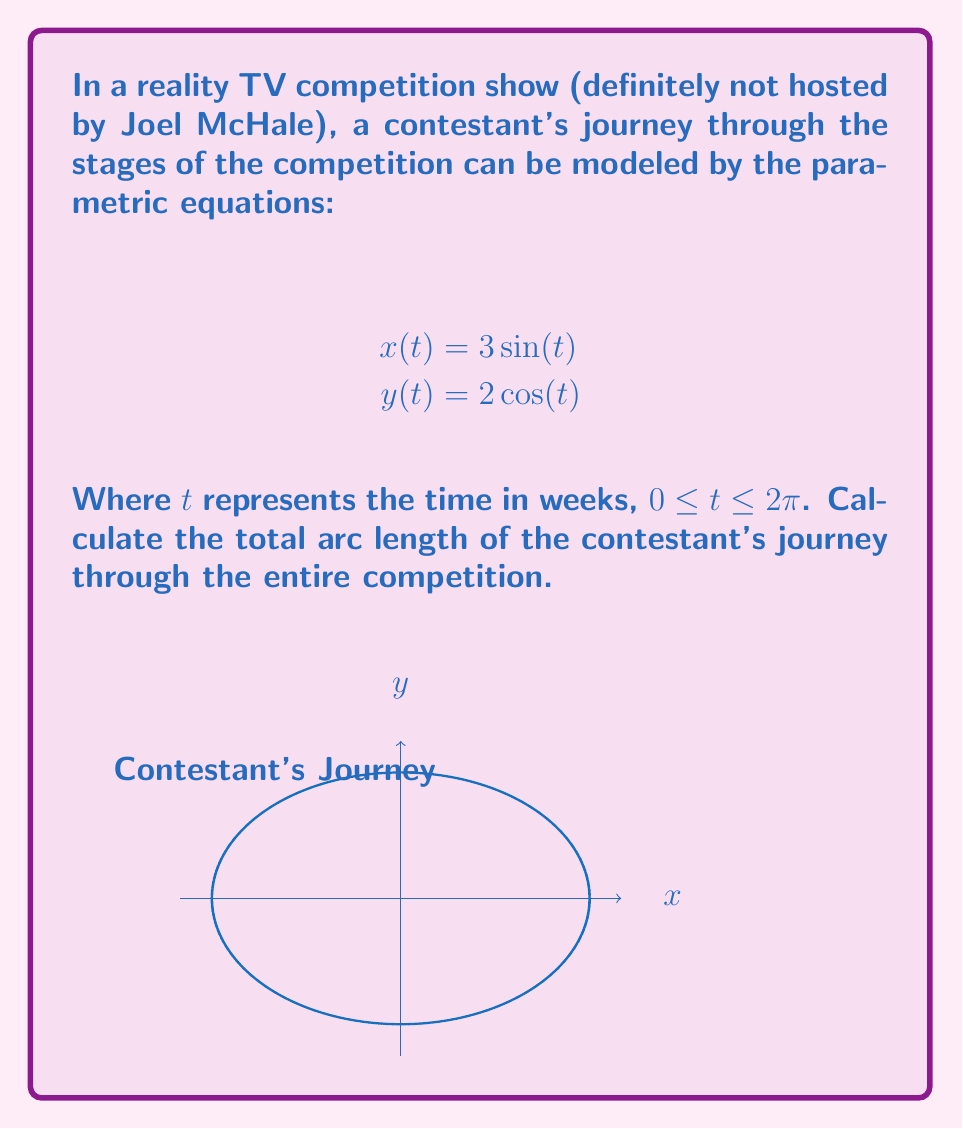Could you help me with this problem? To find the arc length of a parametric curve, we use the formula:

$$L = \int_{a}^{b} \sqrt{\left(\frac{dx}{dt}\right)^2 + \left(\frac{dy}{dt}\right)^2} dt$$

Step 1: Find $\frac{dx}{dt}$ and $\frac{dy}{dt}$
$$\frac{dx}{dt} = 3\cos(t)$$
$$\frac{dy}{dt} = -2\sin(t)$$

Step 2: Substitute into the arc length formula
$$L = \int_{0}^{2\pi} \sqrt{(3\cos(t))^2 + (-2\sin(t))^2} dt$$

Step 3: Simplify under the square root
$$L = \int_{0}^{2\pi} \sqrt{9\cos^2(t) + 4\sin^2(t)} dt$$

Step 4: Factor out the common term
$$L = \int_{0}^{2\pi} \sqrt{9(\cos^2(t) + \frac{4}{9}\sin^2(t))} dt$$
$$L = 3\int_{0}^{2\pi} \sqrt{\cos^2(t) + \frac{4}{9}\sin^2(t)} dt$$

Step 5: Use the identity $\cos^2(t) = 1 - \sin^2(t)$
$$L = 3\int_{0}^{2\pi} \sqrt{(1 - \sin^2(t)) + \frac{4}{9}\sin^2(t)} dt$$
$$L = 3\int_{0}^{2\pi} \sqrt{1 - \frac{5}{9}\sin^2(t)} dt$$

Step 6: This integral is in the form of an elliptic integral of the second kind. The exact solution involves elliptic functions, but we can approximate it numerically:

$$L \approx 3 \cdot 2\pi \cdot 0.9089 \approx 17.1439$$
Answer: $17.1439$ (approximate) 